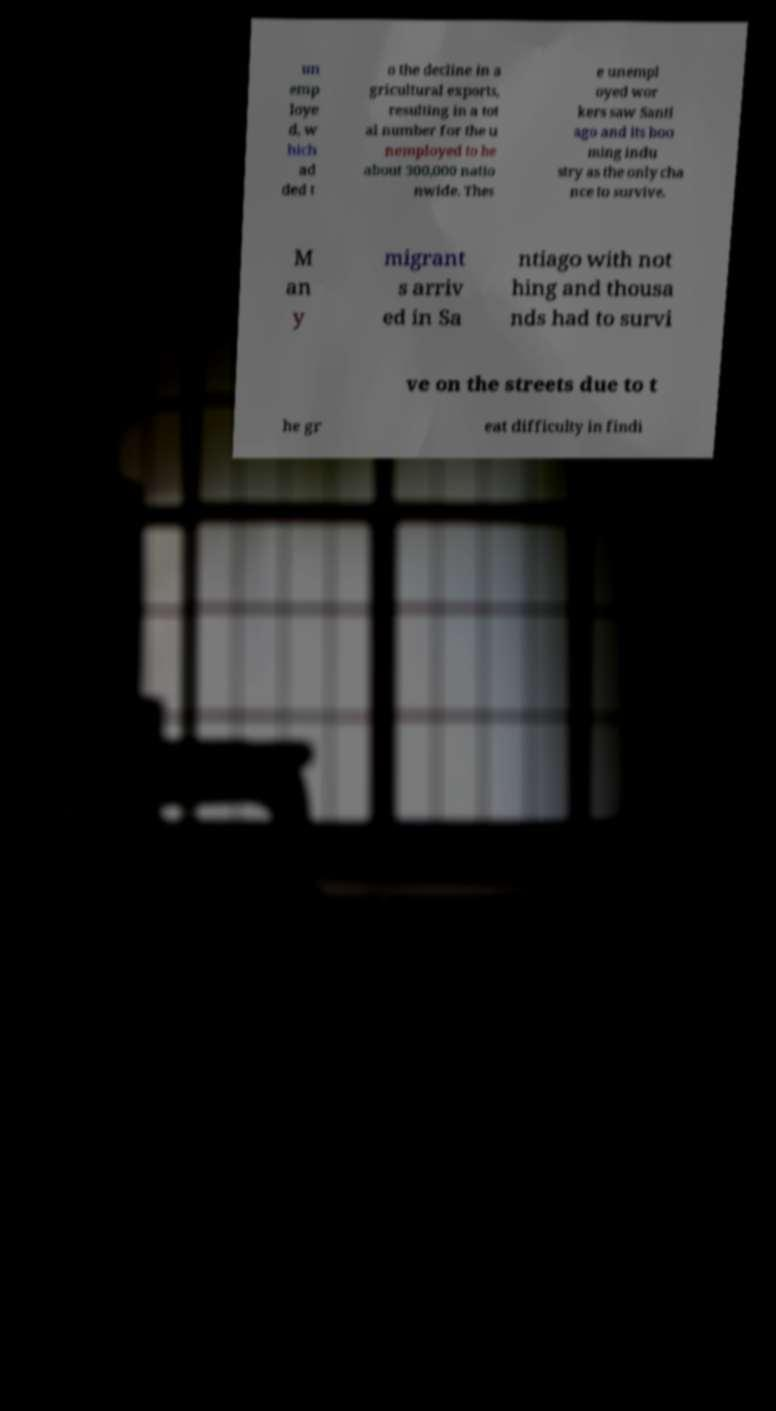Can you read and provide the text displayed in the image?This photo seems to have some interesting text. Can you extract and type it out for me? un emp loye d, w hich ad ded t o the decline in a gricultural exports, resulting in a tot al number for the u nemployed to be about 300,000 natio nwide. Thes e unempl oyed wor kers saw Santi ago and its boo ming indu stry as the only cha nce to survive. M an y migrant s arriv ed in Sa ntiago with not hing and thousa nds had to survi ve on the streets due to t he gr eat difficulty in findi 